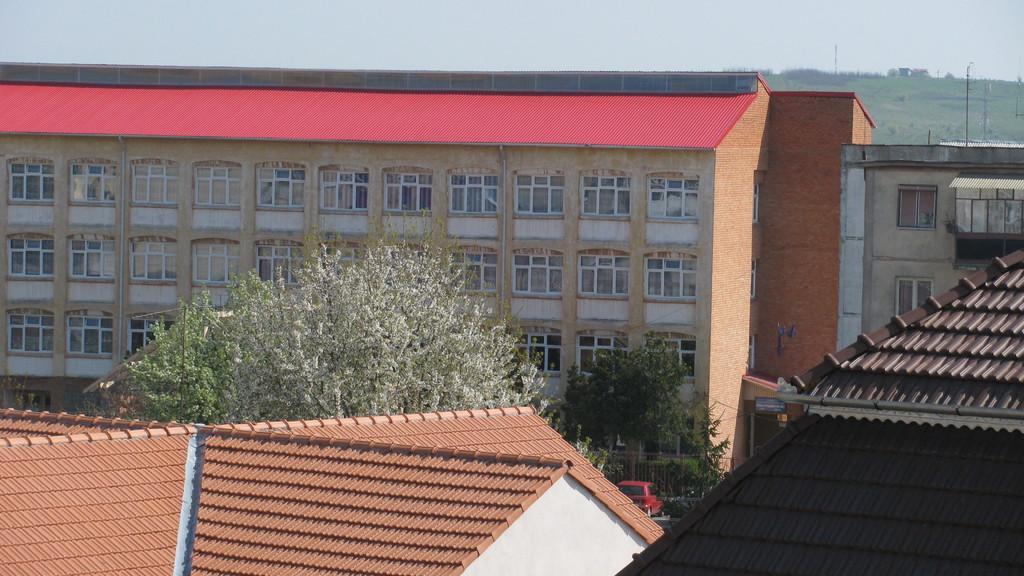In one or two sentences, can you explain what this image depicts? There are two houses at the bottom of this image and there are trees in the background. We can see a building in the middle of this image and there is a sky at the top of this image. 